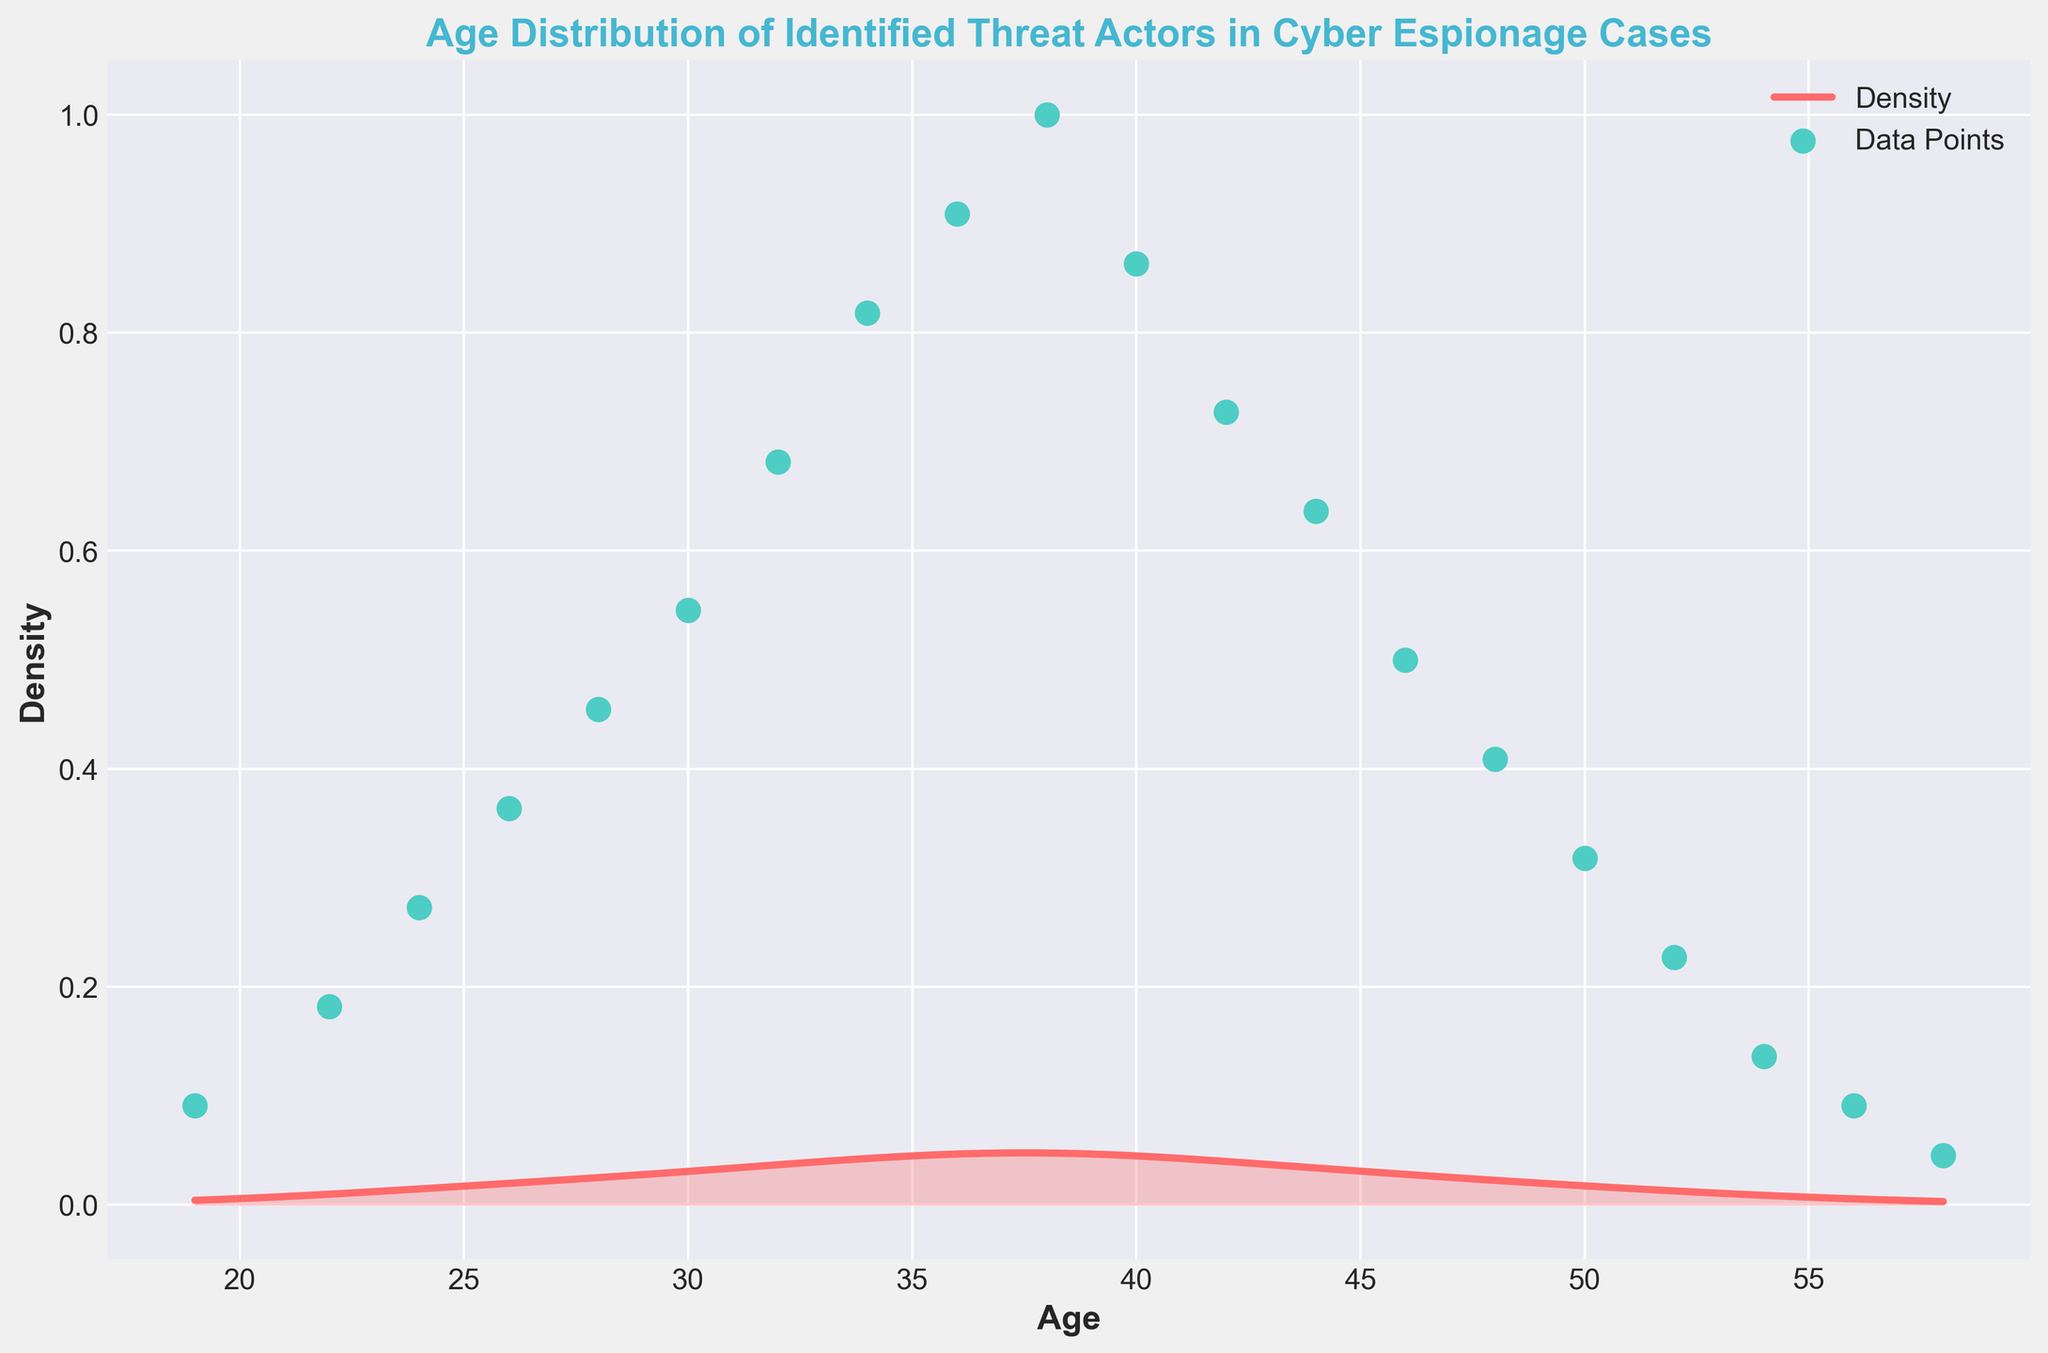what is the title of the figure? The title is clearly displayed at the top of the plot.
Answer: Age Distribution of Identified Threat Actors in Cyber Espionage Cases what does the x-axis represent in the figure? The label on the x-axis specifies what it represents.
Answer: Age what color represents the density area in the figure? The color of the density area can be easily identified from the plot.
Answer: Red how many data points are present in the plot? There are visible points on the plot that represent the data, and they can be counted.
Answer: 20 around which age group is the density highest? Observe the peak of the density curve to determine the age group.
Answer: 38 which age groups have the lowest density? Look for the points where the density curve is near zero.
Answer: 19, 58 what age group has the most counts? The count peaks at a specific age group, and this can be identified by looking at the scatter plot points along the x-axis.
Answer: 38 how does the distribution change from age 30 to 40? Observe the shape of the density curve between these ages to understand the trend.
Answer: It increases, peaks, and then starts to decline between which age groups is the density approximately equal? Compare the height of the density curve at various age groups to find where it is similar.
Answer: 24 and 52 what's the range of ages included in the plot? Check the minimum and maximum values on the x-axis.
Answer: 19 to 58 